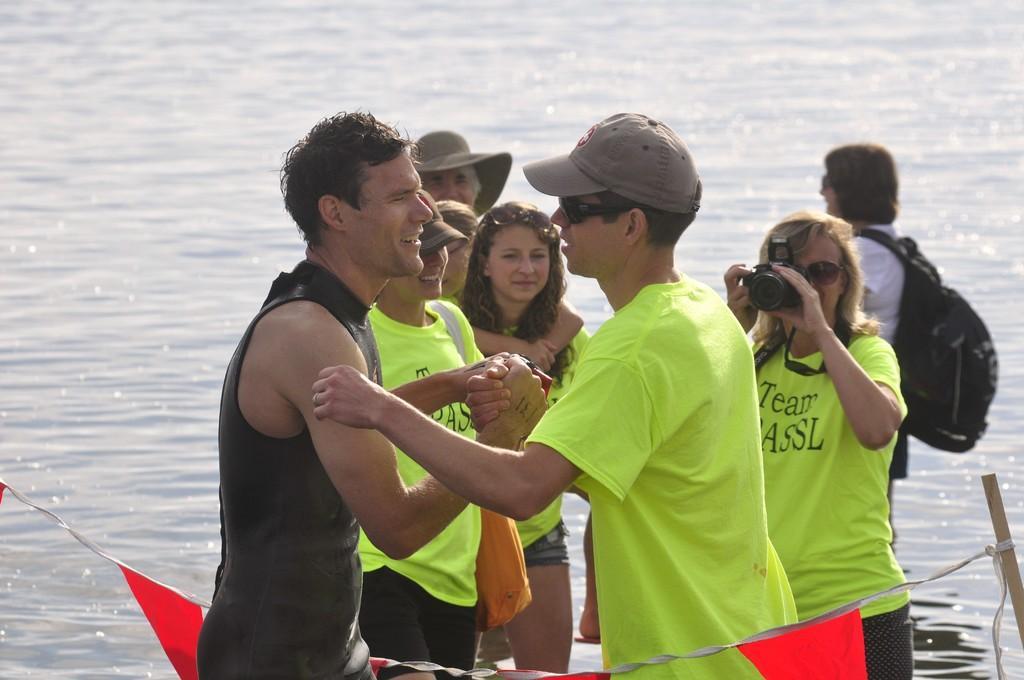In one or two sentences, can you explain what this image depicts? In the foreground of the image there are two people holding hands. In the background of the image there is a lady holding a camera. There are people standing. There is water. In the center of the image there is a rope with flags. 